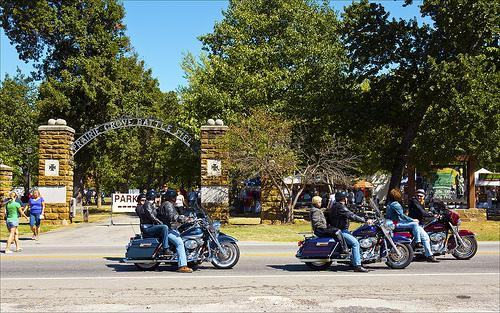Question: how many bike are pictured?
Choices:
A. 3.
B. 2.
C. 1.
D. 0.
Answer with the letter. Answer: A Question: what do the bikers have on their heads?
Choices:
A. Helmets.
B. Hats.
C. Visors.
D. Sunglasses.
Answer with the letter. Answer: A Question: where was the picture taken?
Choices:
A. Park.
B. School.
C. Forest.
D. Ocean.
Answer with the letter. Answer: A Question: what color is the sky?
Choices:
A. Red.
B. Black.
C. Grey.
D. Blue.
Answer with the letter. Answer: D Question: why do the bikers have helmets?
Choices:
A. Safety.
B. Fashion.
C. Team affiliation.
D. Warmth.
Answer with the letter. Answer: A 